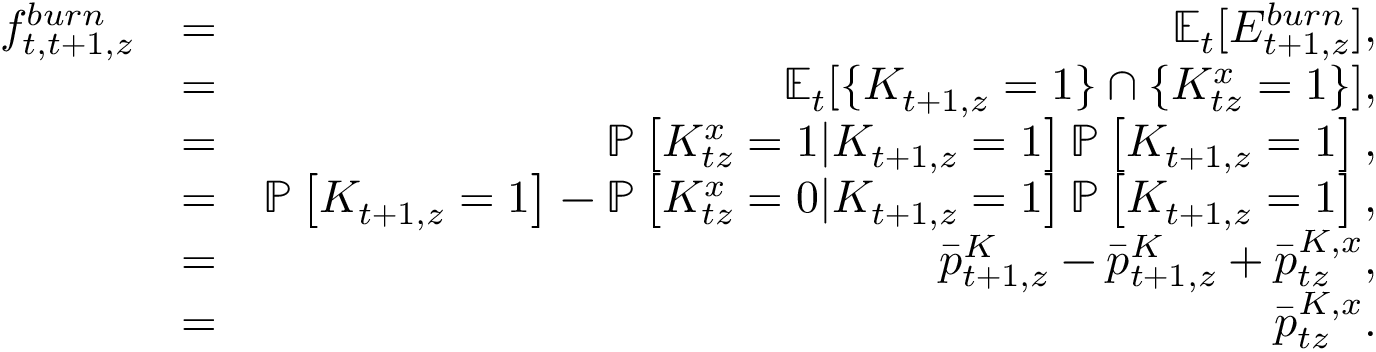<formula> <loc_0><loc_0><loc_500><loc_500>\begin{array} { r l r } { f _ { t , t + 1 , z } ^ { b u r n } } & { = } & { \mathbb { E } _ { t } [ E _ { t + 1 , z } ^ { b u r n } ] , } \\ & { = } & { \mathbb { E } _ { t } [ \{ K _ { t + 1 , z } = 1 \} \cap \{ K _ { t z } ^ { x } = 1 \} ] , } \\ & { = } & { \mathbb { P } \left [ K _ { t z } ^ { x } = 1 | K _ { t + 1 , z } = 1 \right ] \mathbb { P } \left [ K _ { t + 1 , z } = 1 \right ] , } \\ & { = } & { \mathbb { P } \left [ K _ { t + 1 , z } = 1 \right ] - \mathbb { P } \left [ K _ { t z } ^ { x } = 0 | K _ { t + 1 , z } = 1 \right ] \mathbb { P } \left [ K _ { t + 1 , z } = 1 \right ] , } \\ & { = } & { \bar { p } _ { t + 1 , z } ^ { K } - \bar { p } _ { t + 1 , z } ^ { K } + \bar { p } _ { t z } ^ { K , x } , } \\ & { = } & { \bar { p } _ { t z } ^ { K , x } . } \end{array}</formula> 